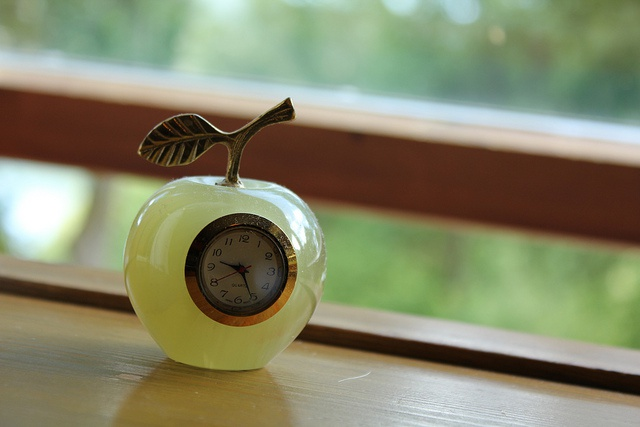Describe the objects in this image and their specific colors. I can see a clock in olive and black tones in this image. 